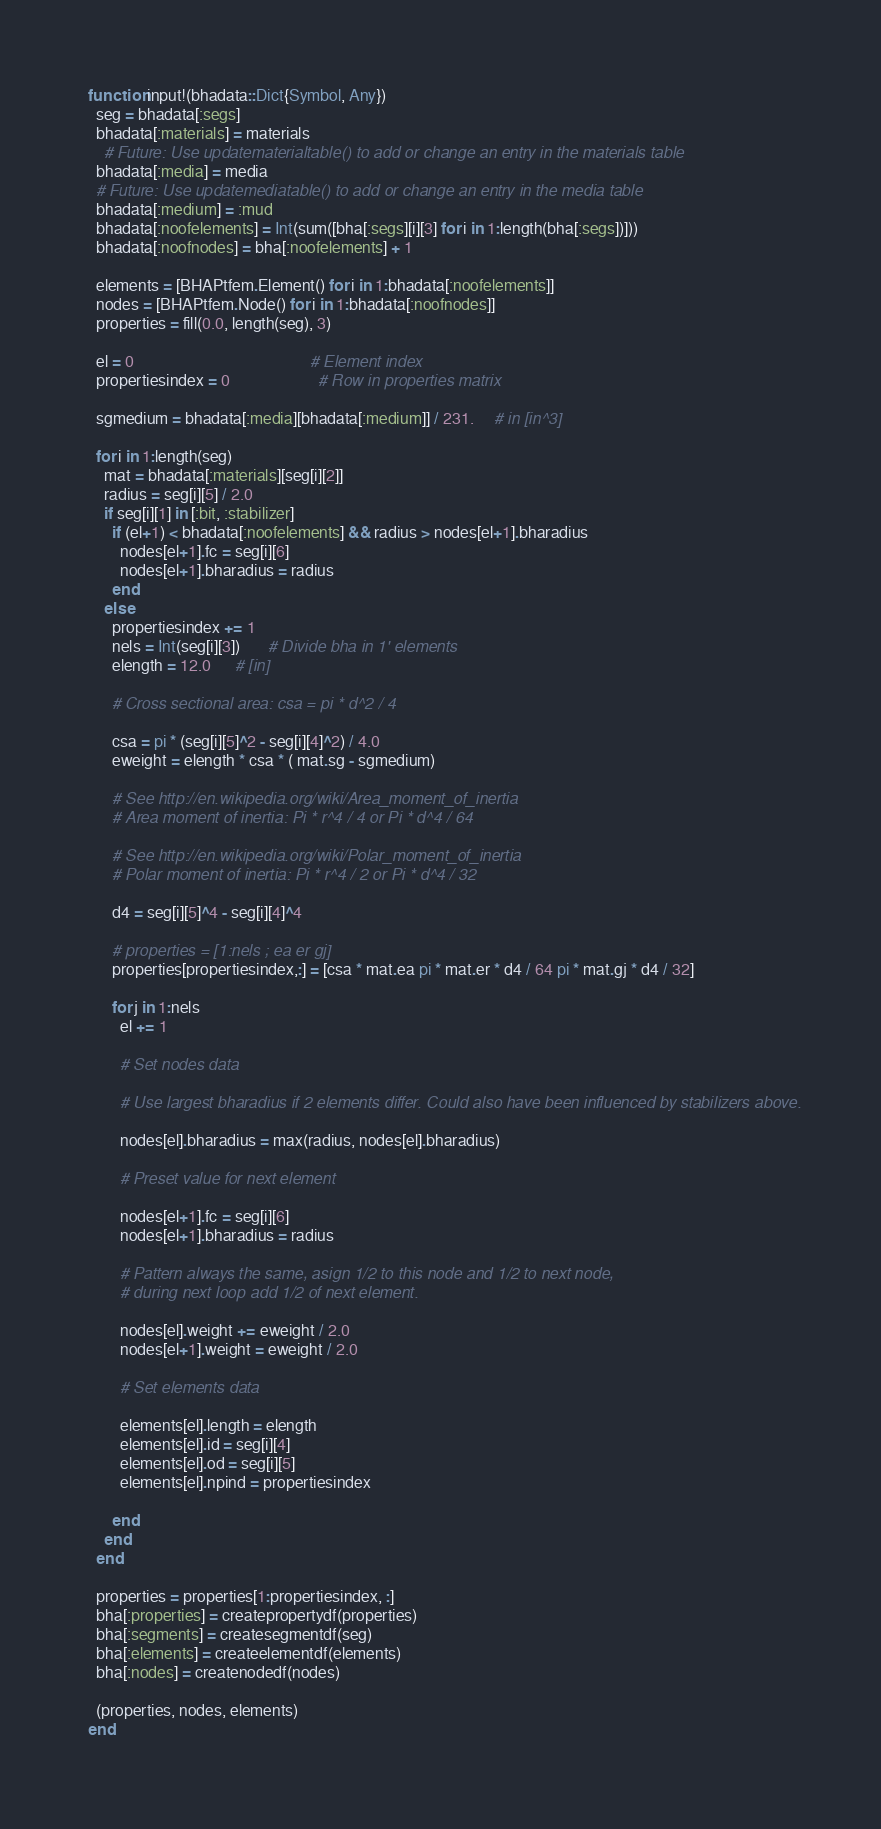Convert code to text. <code><loc_0><loc_0><loc_500><loc_500><_Julia_>function input!(bhadata::Dict{Symbol, Any})
  seg = bhadata[:segs]
  bhadata[:materials] = materials
    # Future: Use updatematerialtable() to add or change an entry in the materials table
  bhadata[:media] = media
  # Future: Use updatemediatable() to add or change an entry in the media table
  bhadata[:medium] = :mud
  bhadata[:noofelements] = Int(sum([bha[:segs][i][3] for i in 1:length(bha[:segs])]))
  bhadata[:noofnodes] = bha[:noofelements] + 1

  elements = [BHAPtfem.Element() for i in 1:bhadata[:noofelements]]
  nodes = [BHAPtfem.Node() for i in 1:bhadata[:noofnodes]]
  properties = fill(0.0, length(seg), 3)

  el = 0                                            # Element index
  propertiesindex = 0                      # Row in properties matrix
  
  sgmedium = bhadata[:media][bhadata[:medium]] / 231.     # in [in^3]
  
  for i in 1:length(seg)
    mat = bhadata[:materials][seg[i][2]]
    radius = seg[i][5] / 2.0
    if seg[i][1] in [:bit, :stabilizer]
      if (el+1) < bhadata[:noofelements] && radius > nodes[el+1].bharadius
        nodes[el+1].fc = seg[i][6]
        nodes[el+1].bharadius = radius
      end
    else
      propertiesindex += 1
      nels = Int(seg[i][3])       # Divide bha in 1' elements
      elength = 12.0      # [in]

      # Cross sectional area: csa = pi * d^2 / 4
      
      csa = pi * (seg[i][5]^2 - seg[i][4]^2) / 4.0
      eweight = elength * csa * ( mat.sg - sgmedium)
      
      # See http://en.wikipedia.org/wiki/Area_moment_of_inertia
      # Area moment of inertia: Pi * r^4 / 4 or Pi * d^4 / 64

      # See http://en.wikipedia.org/wiki/Polar_moment_of_inertia
      # Polar moment of inertia: Pi * r^4 / 2 or Pi * d^4 / 32
      
      d4 = seg[i][5]^4 - seg[i][4]^4
      
      # properties = [1:nels ; ea er gj]
      properties[propertiesindex,:] = [csa * mat.ea pi * mat.er * d4 / 64 pi * mat.gj * d4 / 32]

      for j in 1:nels
      	el += 1
        
        # Set nodes data
	
		# Use largest bharadius if 2 elements differ. Could also have been influenced by stabilizers above.
		
		nodes[el].bharadius = max(radius, nodes[el].bharadius)
    
        # Preset value for next element
        
		nodes[el+1].fc = seg[i][6]
		nodes[el+1].bharadius = radius

		# Pattern always the same, asign 1/2 to this node and 1/2 to next node,
		# during next loop add 1/2 of next element.

		nodes[el].weight += eweight / 2.0
		nodes[el+1].weight = eweight / 2.0

		# Set elements data

		elements[el].length = elength
		elements[el].id = seg[i][4]
		elements[el].od = seg[i][5]
        elements[el].npind = propertiesindex
        
      end
    end
  end
  
  properties = properties[1:propertiesindex, :]
  bha[:properties] = createpropertydf(properties)
  bha[:segments] = createsegmentdf(seg)
  bha[:elements] = createelementdf(elements)
  bha[:nodes] = createnodedf(nodes)
  
  (properties, nodes, elements)
end</code> 